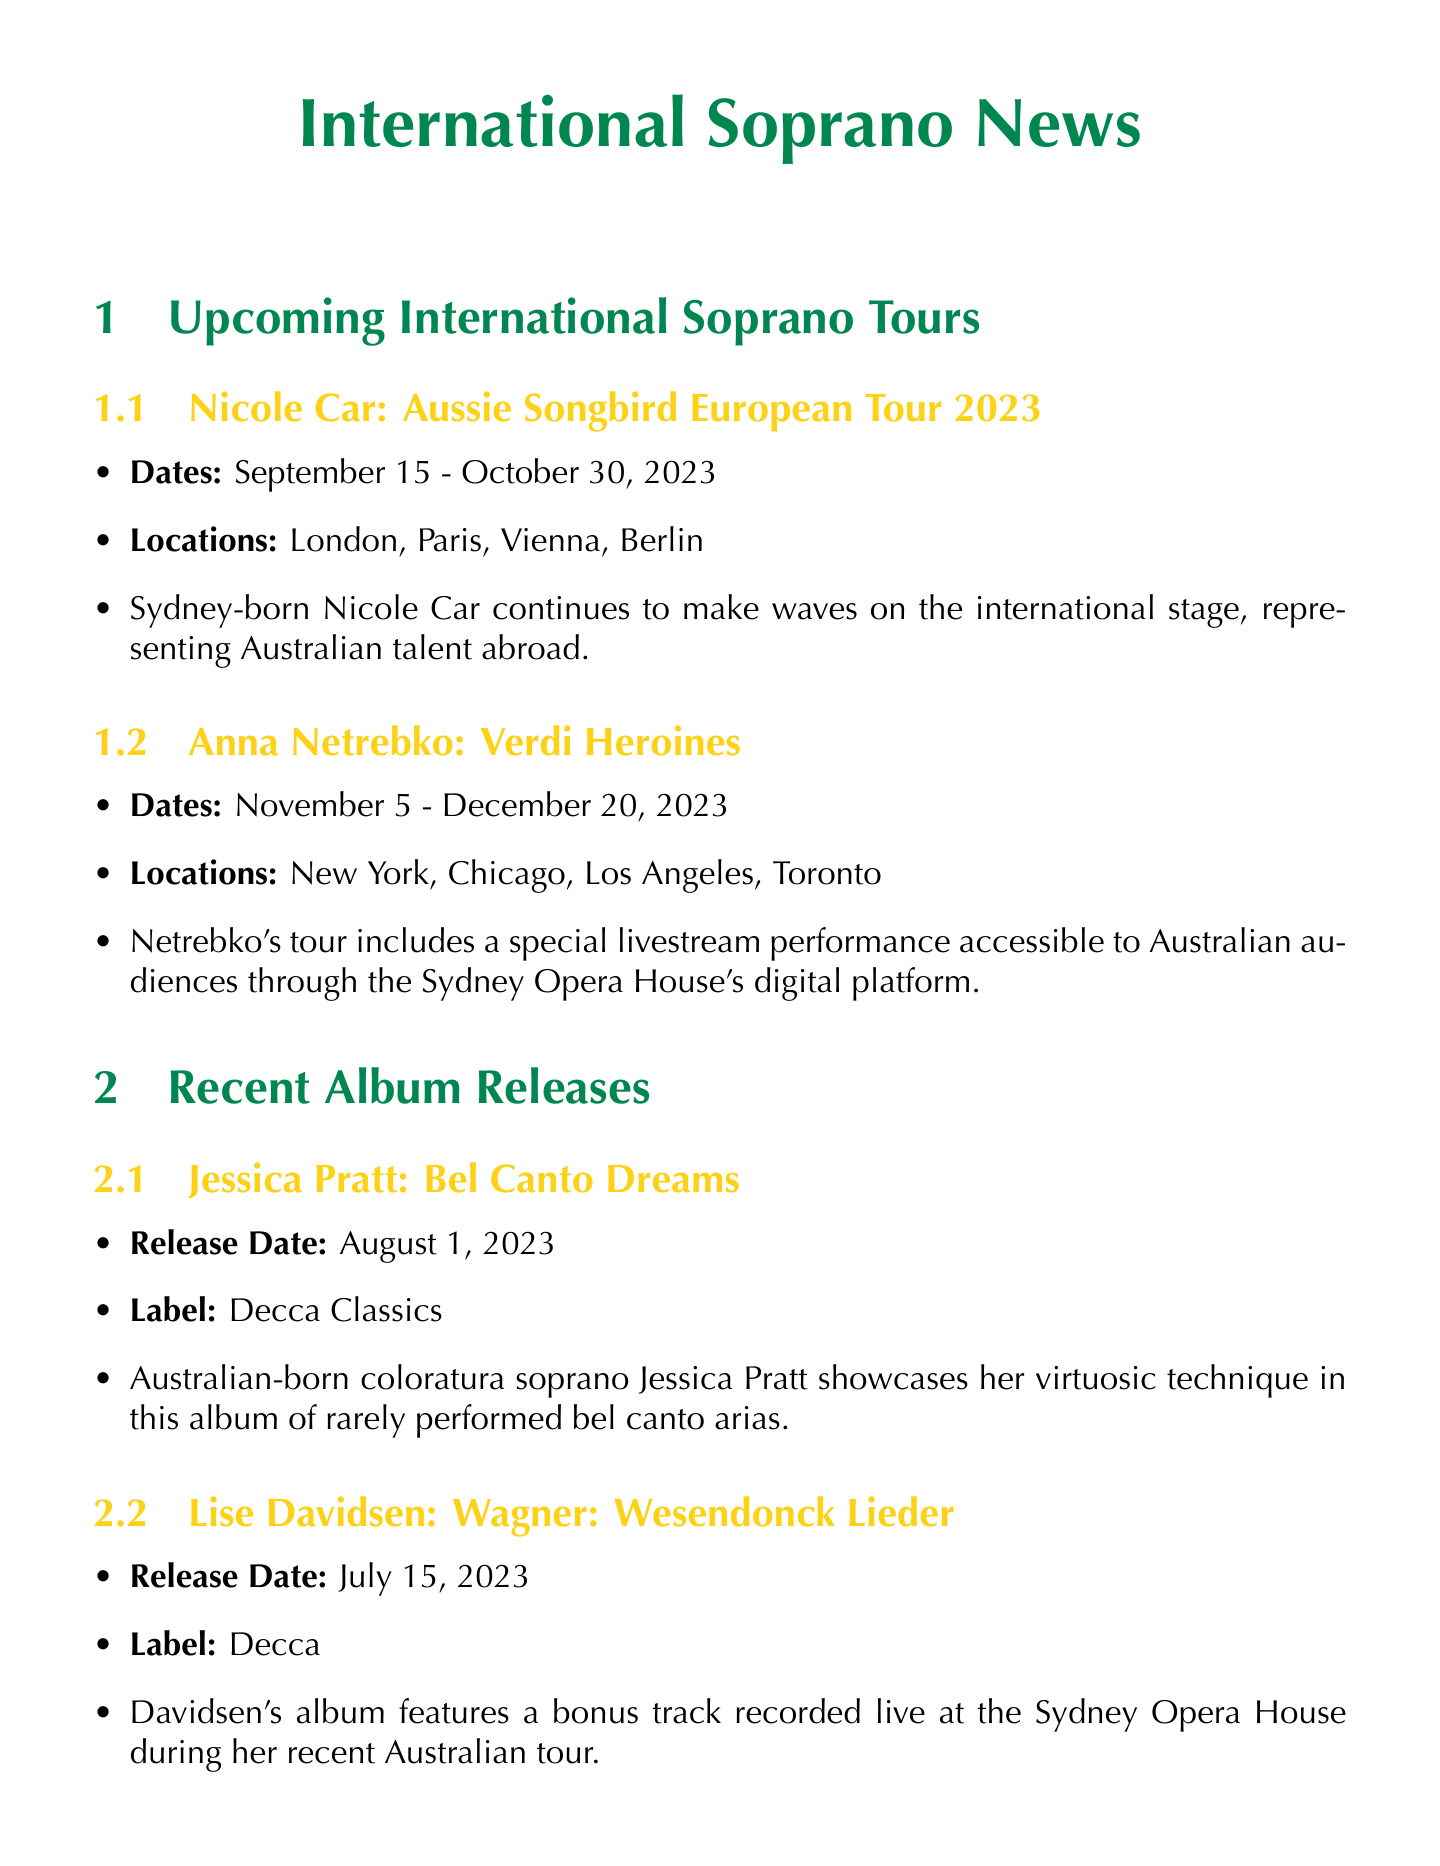What are the dates of Nicole Car's tour? The dates for Nicole Car's tour are listed as September 15 - October 30, 2023, in the document.
Answer: September 15 - October 30, 2023 Where will Anna Netrebko perform? The document lists locations for Anna Netrebko's performances, which include New York, Chicago, Los Angeles, and Toronto.
Answer: New York, Chicago, Los Angeles, Toronto What is the title of Jessica Pratt's album? The document specifies that Jessica Pratt's album is titled "Bel Canto Dreams."
Answer: Bel Canto Dreams Who won the Female Singer of the Year at the International Opera Awards 2023? According to the document, Ermonela Jaho is named as the winner of the Female Singer of the Year category.
Answer: Ermonela Jaho Which Australian soprano debuted at Teatro alla Scala? The document notes Siobhan Stagg as the artist who debuted at Teatro alla Scala.
Answer: Siobhan Stagg What is the label for Lise Davidsen's album? The document provides the information that Lise Davidsen's album is released under the Decca label.
Answer: Decca What special feature does Anna Netrebko's tour include for Australian audiences? The document mentions that Anna Netrebko's tour includes a special livestream performance for Australian audiences.
Answer: Livestream performance How many major productions will Lauren Fagan perform in during her residency? The document indicates that Lauren Fagan will perform in three major productions during her residency.
Answer: Three Which award did Sonya Yoncheva win at the Gramophone Classical Music Awards 2023? The document states that Sonya Yoncheva won for her album "Rebirth" in the Recital category.
Answer: Recital 